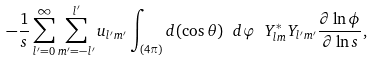<formula> <loc_0><loc_0><loc_500><loc_500>- \frac { 1 } { s } \sum _ { l ^ { \prime } = 0 } ^ { \infty } \sum _ { m ^ { \prime } = - l ^ { \prime } } ^ { l ^ { \prime } } u _ { l ^ { \prime } m ^ { \prime } } \int _ { ( 4 \pi ) } d ( \cos \theta ) \ d \varphi \ Y _ { l m } ^ { * } Y _ { l ^ { \prime } m ^ { \prime } } \frac { \partial \ln \phi } { \partial \ln s } ,</formula> 